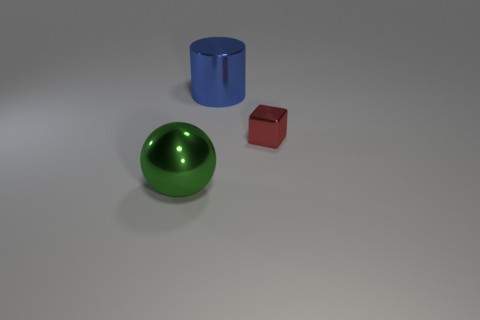Are there any big metal things on the right side of the metallic ball?
Offer a terse response. Yes. Does the red metal object have the same size as the thing that is on the left side of the big blue thing?
Make the answer very short. No. There is a object right of the thing that is behind the red shiny object; what color is it?
Give a very brief answer. Red. Do the green metal thing and the metallic cylinder have the same size?
Keep it short and to the point. Yes. The thing that is both on the left side of the tiny cube and behind the green object is what color?
Your answer should be compact. Blue. The blue metallic cylinder has what size?
Keep it short and to the point. Large. Are there more metal balls that are behind the big shiny cylinder than red objects on the right side of the large green sphere?
Your answer should be very brief. No. Is the number of metal blocks greater than the number of big blue cubes?
Your response must be concise. Yes. There is a thing that is both to the right of the green shiny sphere and in front of the big blue shiny cylinder; what is its size?
Provide a short and direct response. Small. There is a big green metal object; what shape is it?
Your answer should be compact. Sphere. 